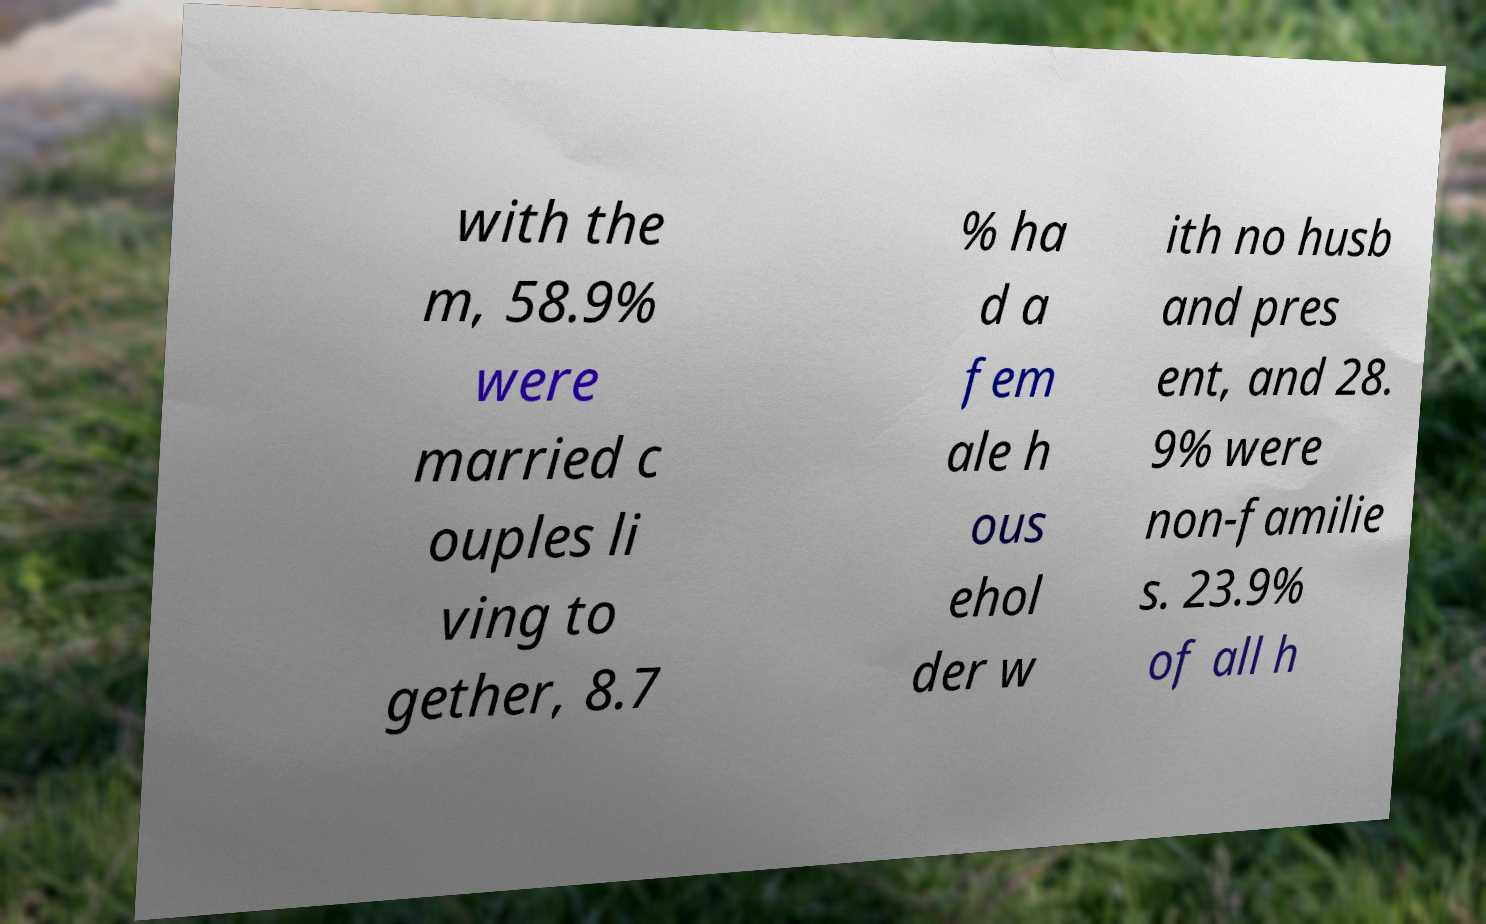Could you extract and type out the text from this image? with the m, 58.9% were married c ouples li ving to gether, 8.7 % ha d a fem ale h ous ehol der w ith no husb and pres ent, and 28. 9% were non-familie s. 23.9% of all h 